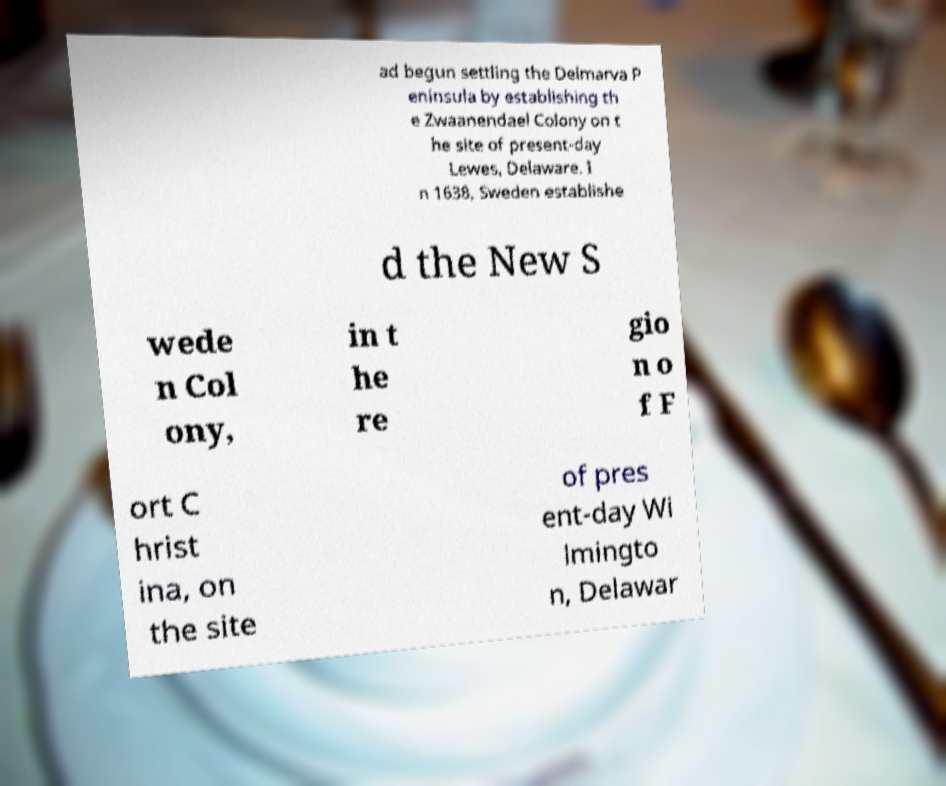Can you read and provide the text displayed in the image?This photo seems to have some interesting text. Can you extract and type it out for me? ad begun settling the Delmarva P eninsula by establishing th e Zwaanendael Colony on t he site of present-day Lewes, Delaware. I n 1638, Sweden establishe d the New S wede n Col ony, in t he re gio n o f F ort C hrist ina, on the site of pres ent-day Wi lmingto n, Delawar 